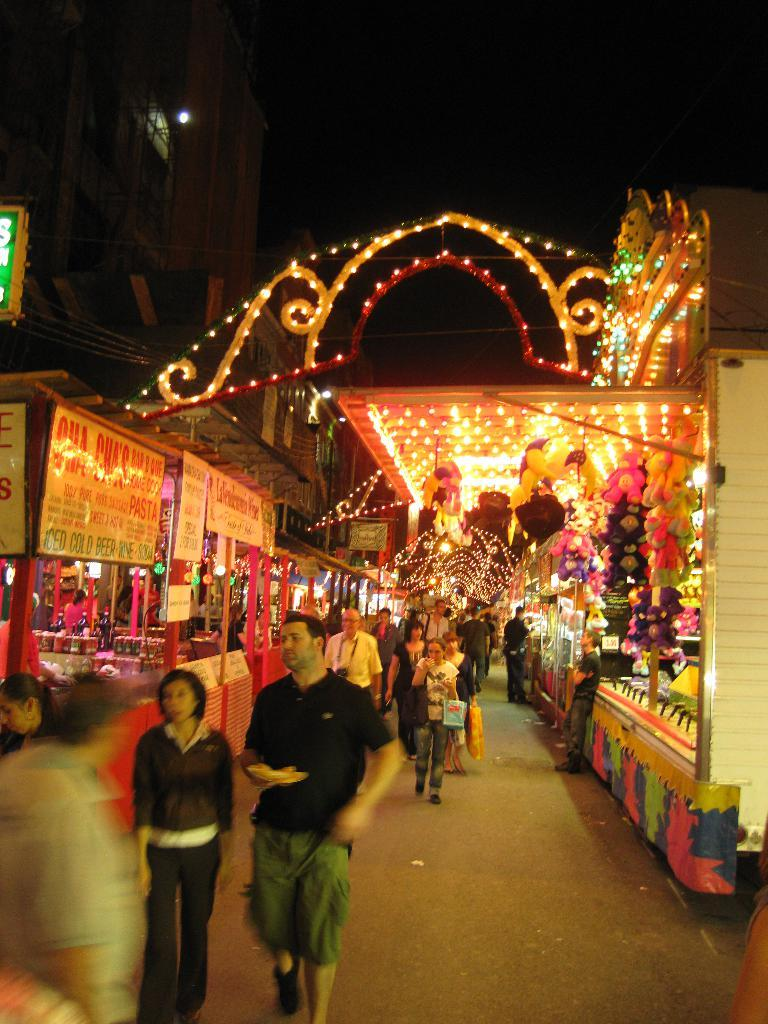Who or what can be seen in the image? There are people in the image. What is the primary setting of the image? There is a road in the image. What objects are present in the image? There are boards, lights, and stalls in the image. What type of structure is visible in the image? There is a building in the image. How would you describe the lighting conditions in the image? The background of the image is dark. What type of ticket is being sold at the stalls in the image? There is no mention of tickets or any items being sold at the stalls in the image. 